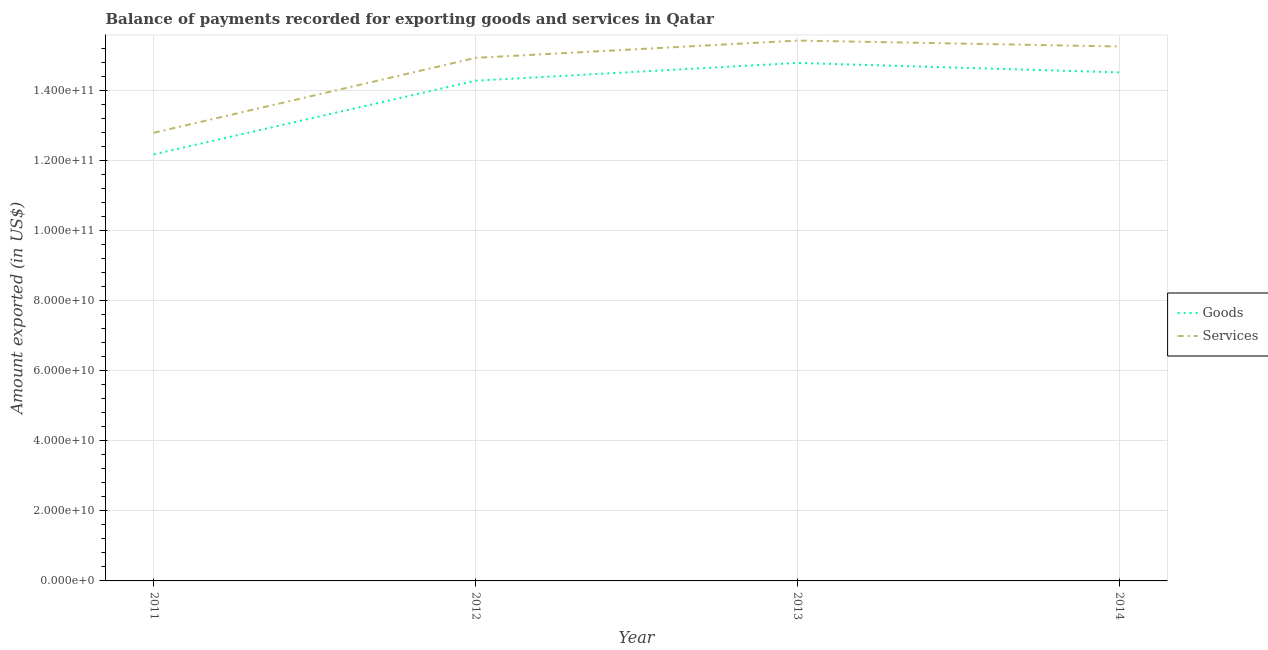How many different coloured lines are there?
Keep it short and to the point. 2. Is the number of lines equal to the number of legend labels?
Your answer should be very brief. Yes. What is the amount of services exported in 2012?
Offer a very short reply. 1.49e+11. Across all years, what is the maximum amount of services exported?
Offer a very short reply. 1.54e+11. Across all years, what is the minimum amount of services exported?
Give a very brief answer. 1.28e+11. What is the total amount of goods exported in the graph?
Your response must be concise. 5.58e+11. What is the difference between the amount of goods exported in 2013 and that in 2014?
Your answer should be compact. 2.70e+09. What is the difference between the amount of services exported in 2014 and the amount of goods exported in 2011?
Your answer should be compact. 3.08e+1. What is the average amount of goods exported per year?
Provide a succinct answer. 1.39e+11. In the year 2014, what is the difference between the amount of goods exported and amount of services exported?
Offer a terse response. -7.40e+09. What is the ratio of the amount of goods exported in 2012 to that in 2013?
Give a very brief answer. 0.97. Is the amount of services exported in 2011 less than that in 2014?
Your answer should be compact. Yes. What is the difference between the highest and the second highest amount of goods exported?
Give a very brief answer. 2.70e+09. What is the difference between the highest and the lowest amount of goods exported?
Make the answer very short. 2.61e+1. In how many years, is the amount of services exported greater than the average amount of services exported taken over all years?
Your answer should be very brief. 3. Is the amount of services exported strictly greater than the amount of goods exported over the years?
Your answer should be compact. Yes. How many lines are there?
Ensure brevity in your answer.  2. How many years are there in the graph?
Offer a very short reply. 4. Does the graph contain any zero values?
Your answer should be compact. No. Where does the legend appear in the graph?
Offer a terse response. Center right. How many legend labels are there?
Your answer should be compact. 2. How are the legend labels stacked?
Ensure brevity in your answer.  Vertical. What is the title of the graph?
Make the answer very short. Balance of payments recorded for exporting goods and services in Qatar. What is the label or title of the Y-axis?
Offer a terse response. Amount exported (in US$). What is the Amount exported (in US$) of Goods in 2011?
Provide a short and direct response. 1.22e+11. What is the Amount exported (in US$) of Services in 2011?
Provide a short and direct response. 1.28e+11. What is the Amount exported (in US$) of Goods in 2012?
Make the answer very short. 1.43e+11. What is the Amount exported (in US$) of Services in 2012?
Provide a succinct answer. 1.49e+11. What is the Amount exported (in US$) in Goods in 2013?
Provide a short and direct response. 1.48e+11. What is the Amount exported (in US$) of Services in 2013?
Your answer should be compact. 1.54e+11. What is the Amount exported (in US$) in Goods in 2014?
Your response must be concise. 1.45e+11. What is the Amount exported (in US$) of Services in 2014?
Provide a short and direct response. 1.53e+11. Across all years, what is the maximum Amount exported (in US$) in Goods?
Keep it short and to the point. 1.48e+11. Across all years, what is the maximum Amount exported (in US$) of Services?
Give a very brief answer. 1.54e+11. Across all years, what is the minimum Amount exported (in US$) of Goods?
Give a very brief answer. 1.22e+11. Across all years, what is the minimum Amount exported (in US$) in Services?
Provide a succinct answer. 1.28e+11. What is the total Amount exported (in US$) in Goods in the graph?
Your answer should be compact. 5.58e+11. What is the total Amount exported (in US$) of Services in the graph?
Your answer should be compact. 5.84e+11. What is the difference between the Amount exported (in US$) of Goods in 2011 and that in 2012?
Offer a very short reply. -2.10e+1. What is the difference between the Amount exported (in US$) in Services in 2011 and that in 2012?
Make the answer very short. -2.14e+1. What is the difference between the Amount exported (in US$) of Goods in 2011 and that in 2013?
Ensure brevity in your answer.  -2.61e+1. What is the difference between the Amount exported (in US$) of Services in 2011 and that in 2013?
Ensure brevity in your answer.  -2.63e+1. What is the difference between the Amount exported (in US$) of Goods in 2011 and that in 2014?
Provide a short and direct response. -2.34e+1. What is the difference between the Amount exported (in US$) of Services in 2011 and that in 2014?
Your response must be concise. -2.46e+1. What is the difference between the Amount exported (in US$) of Goods in 2012 and that in 2013?
Your answer should be very brief. -5.07e+09. What is the difference between the Amount exported (in US$) in Services in 2012 and that in 2013?
Provide a short and direct response. -4.94e+09. What is the difference between the Amount exported (in US$) of Goods in 2012 and that in 2014?
Your answer should be very brief. -2.37e+09. What is the difference between the Amount exported (in US$) in Services in 2012 and that in 2014?
Make the answer very short. -3.24e+09. What is the difference between the Amount exported (in US$) of Goods in 2013 and that in 2014?
Offer a very short reply. 2.70e+09. What is the difference between the Amount exported (in US$) in Services in 2013 and that in 2014?
Your answer should be compact. 1.69e+09. What is the difference between the Amount exported (in US$) in Goods in 2011 and the Amount exported (in US$) in Services in 2012?
Provide a succinct answer. -2.76e+1. What is the difference between the Amount exported (in US$) in Goods in 2011 and the Amount exported (in US$) in Services in 2013?
Your answer should be very brief. -3.25e+1. What is the difference between the Amount exported (in US$) of Goods in 2011 and the Amount exported (in US$) of Services in 2014?
Your answer should be very brief. -3.08e+1. What is the difference between the Amount exported (in US$) in Goods in 2012 and the Amount exported (in US$) in Services in 2013?
Ensure brevity in your answer.  -1.15e+1. What is the difference between the Amount exported (in US$) of Goods in 2012 and the Amount exported (in US$) of Services in 2014?
Offer a very short reply. -9.76e+09. What is the difference between the Amount exported (in US$) of Goods in 2013 and the Amount exported (in US$) of Services in 2014?
Keep it short and to the point. -4.70e+09. What is the average Amount exported (in US$) in Goods per year?
Provide a succinct answer. 1.39e+11. What is the average Amount exported (in US$) in Services per year?
Your answer should be compact. 1.46e+11. In the year 2011, what is the difference between the Amount exported (in US$) of Goods and Amount exported (in US$) of Services?
Your answer should be compact. -6.17e+09. In the year 2012, what is the difference between the Amount exported (in US$) of Goods and Amount exported (in US$) of Services?
Your answer should be compact. -6.52e+09. In the year 2013, what is the difference between the Amount exported (in US$) of Goods and Amount exported (in US$) of Services?
Your response must be concise. -6.39e+09. In the year 2014, what is the difference between the Amount exported (in US$) of Goods and Amount exported (in US$) of Services?
Your response must be concise. -7.40e+09. What is the ratio of the Amount exported (in US$) of Goods in 2011 to that in 2012?
Ensure brevity in your answer.  0.85. What is the ratio of the Amount exported (in US$) of Services in 2011 to that in 2012?
Your answer should be compact. 0.86. What is the ratio of the Amount exported (in US$) in Goods in 2011 to that in 2013?
Your answer should be very brief. 0.82. What is the ratio of the Amount exported (in US$) in Services in 2011 to that in 2013?
Provide a succinct answer. 0.83. What is the ratio of the Amount exported (in US$) in Goods in 2011 to that in 2014?
Your response must be concise. 0.84. What is the ratio of the Amount exported (in US$) of Services in 2011 to that in 2014?
Keep it short and to the point. 0.84. What is the ratio of the Amount exported (in US$) in Goods in 2012 to that in 2013?
Keep it short and to the point. 0.97. What is the ratio of the Amount exported (in US$) in Goods in 2012 to that in 2014?
Provide a short and direct response. 0.98. What is the ratio of the Amount exported (in US$) in Services in 2012 to that in 2014?
Keep it short and to the point. 0.98. What is the ratio of the Amount exported (in US$) in Goods in 2013 to that in 2014?
Provide a short and direct response. 1.02. What is the ratio of the Amount exported (in US$) in Services in 2013 to that in 2014?
Keep it short and to the point. 1.01. What is the difference between the highest and the second highest Amount exported (in US$) of Goods?
Your answer should be compact. 2.70e+09. What is the difference between the highest and the second highest Amount exported (in US$) in Services?
Offer a terse response. 1.69e+09. What is the difference between the highest and the lowest Amount exported (in US$) of Goods?
Keep it short and to the point. 2.61e+1. What is the difference between the highest and the lowest Amount exported (in US$) in Services?
Offer a terse response. 2.63e+1. 